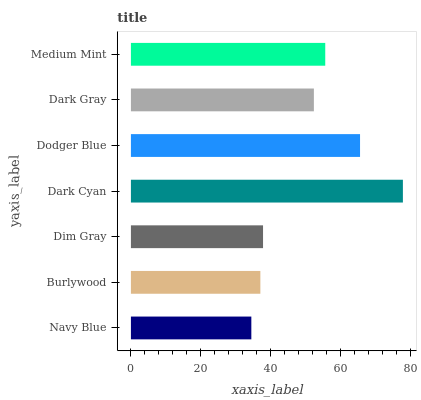Is Navy Blue the minimum?
Answer yes or no. Yes. Is Dark Cyan the maximum?
Answer yes or no. Yes. Is Burlywood the minimum?
Answer yes or no. No. Is Burlywood the maximum?
Answer yes or no. No. Is Burlywood greater than Navy Blue?
Answer yes or no. Yes. Is Navy Blue less than Burlywood?
Answer yes or no. Yes. Is Navy Blue greater than Burlywood?
Answer yes or no. No. Is Burlywood less than Navy Blue?
Answer yes or no. No. Is Dark Gray the high median?
Answer yes or no. Yes. Is Dark Gray the low median?
Answer yes or no. Yes. Is Navy Blue the high median?
Answer yes or no. No. Is Medium Mint the low median?
Answer yes or no. No. 